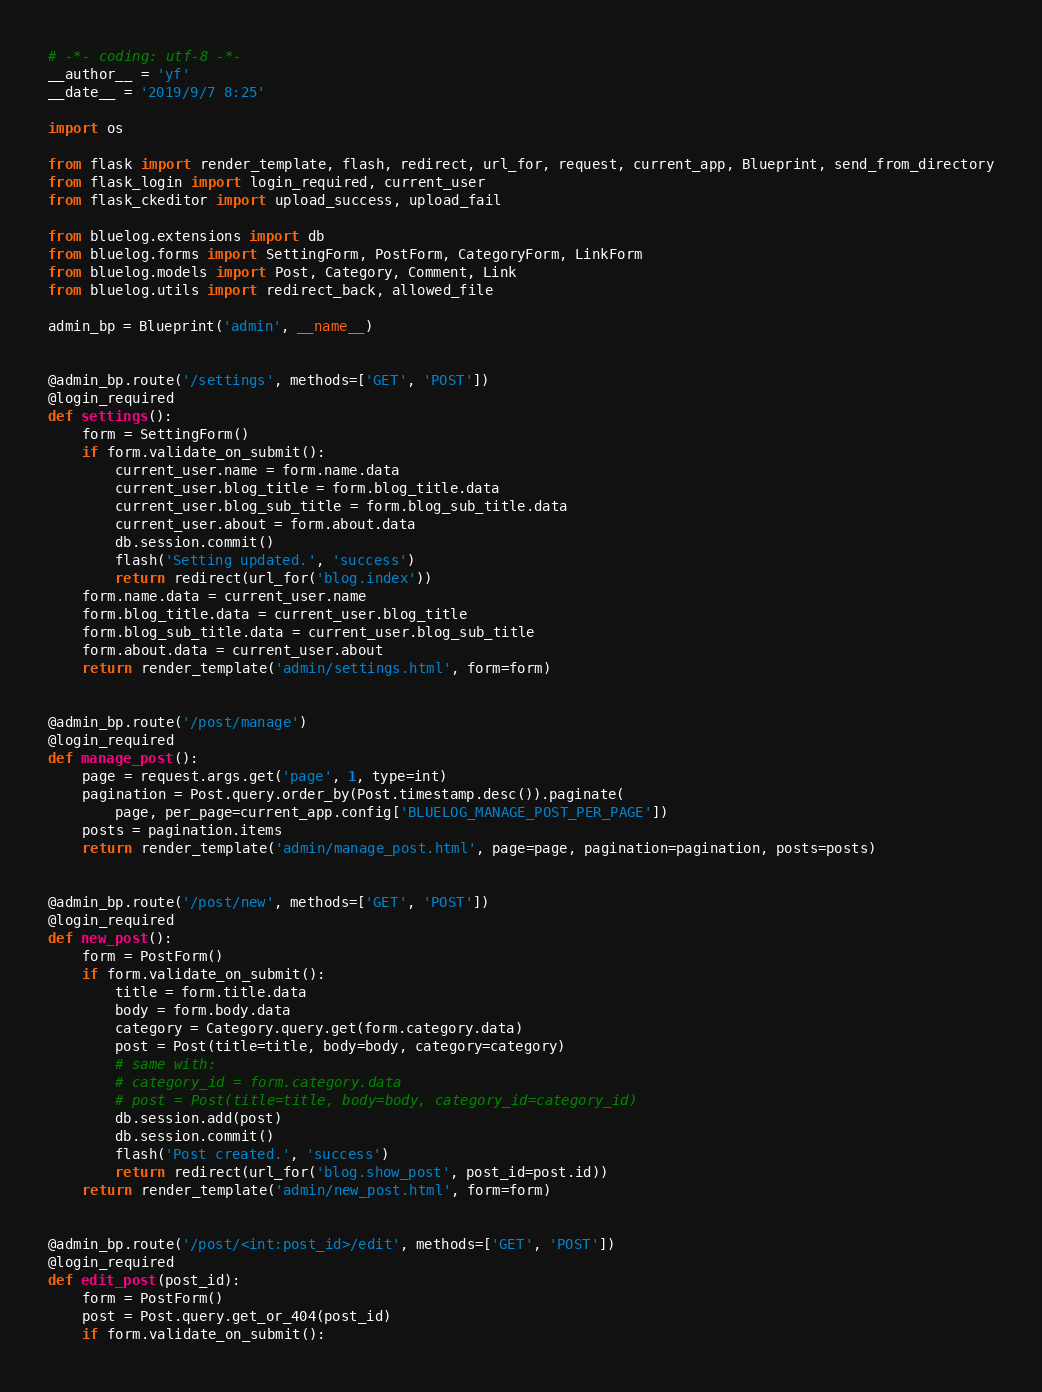<code> <loc_0><loc_0><loc_500><loc_500><_Python_># -*- coding: utf-8 -*-
__author__ = 'yf'
__date__ = '2019/9/7 8:25'

import os

from flask import render_template, flash, redirect, url_for, request, current_app, Blueprint, send_from_directory
from flask_login import login_required, current_user
from flask_ckeditor import upload_success, upload_fail

from bluelog.extensions import db
from bluelog.forms import SettingForm, PostForm, CategoryForm, LinkForm
from bluelog.models import Post, Category, Comment, Link
from bluelog.utils import redirect_back, allowed_file

admin_bp = Blueprint('admin', __name__)


@admin_bp.route('/settings', methods=['GET', 'POST'])
@login_required
def settings():
    form = SettingForm()
    if form.validate_on_submit():
        current_user.name = form.name.data
        current_user.blog_title = form.blog_title.data
        current_user.blog_sub_title = form.blog_sub_title.data
        current_user.about = form.about.data
        db.session.commit()
        flash('Setting updated.', 'success')
        return redirect(url_for('blog.index'))
    form.name.data = current_user.name
    form.blog_title.data = current_user.blog_title
    form.blog_sub_title.data = current_user.blog_sub_title
    form.about.data = current_user.about
    return render_template('admin/settings.html', form=form)


@admin_bp.route('/post/manage')
@login_required
def manage_post():
    page = request.args.get('page', 1, type=int)
    pagination = Post.query.order_by(Post.timestamp.desc()).paginate(
        page, per_page=current_app.config['BLUELOG_MANAGE_POST_PER_PAGE'])
    posts = pagination.items
    return render_template('admin/manage_post.html', page=page, pagination=pagination, posts=posts)


@admin_bp.route('/post/new', methods=['GET', 'POST'])
@login_required
def new_post():
    form = PostForm()
    if form.validate_on_submit():
        title = form.title.data
        body = form.body.data
        category = Category.query.get(form.category.data)
        post = Post(title=title, body=body, category=category)
        # same with:
        # category_id = form.category.data
        # post = Post(title=title, body=body, category_id=category_id)
        db.session.add(post)
        db.session.commit()
        flash('Post created.', 'success')
        return redirect(url_for('blog.show_post', post_id=post.id))
    return render_template('admin/new_post.html', form=form)


@admin_bp.route('/post/<int:post_id>/edit', methods=['GET', 'POST'])
@login_required
def edit_post(post_id):
    form = PostForm()
    post = Post.query.get_or_404(post_id)
    if form.validate_on_submit():</code> 